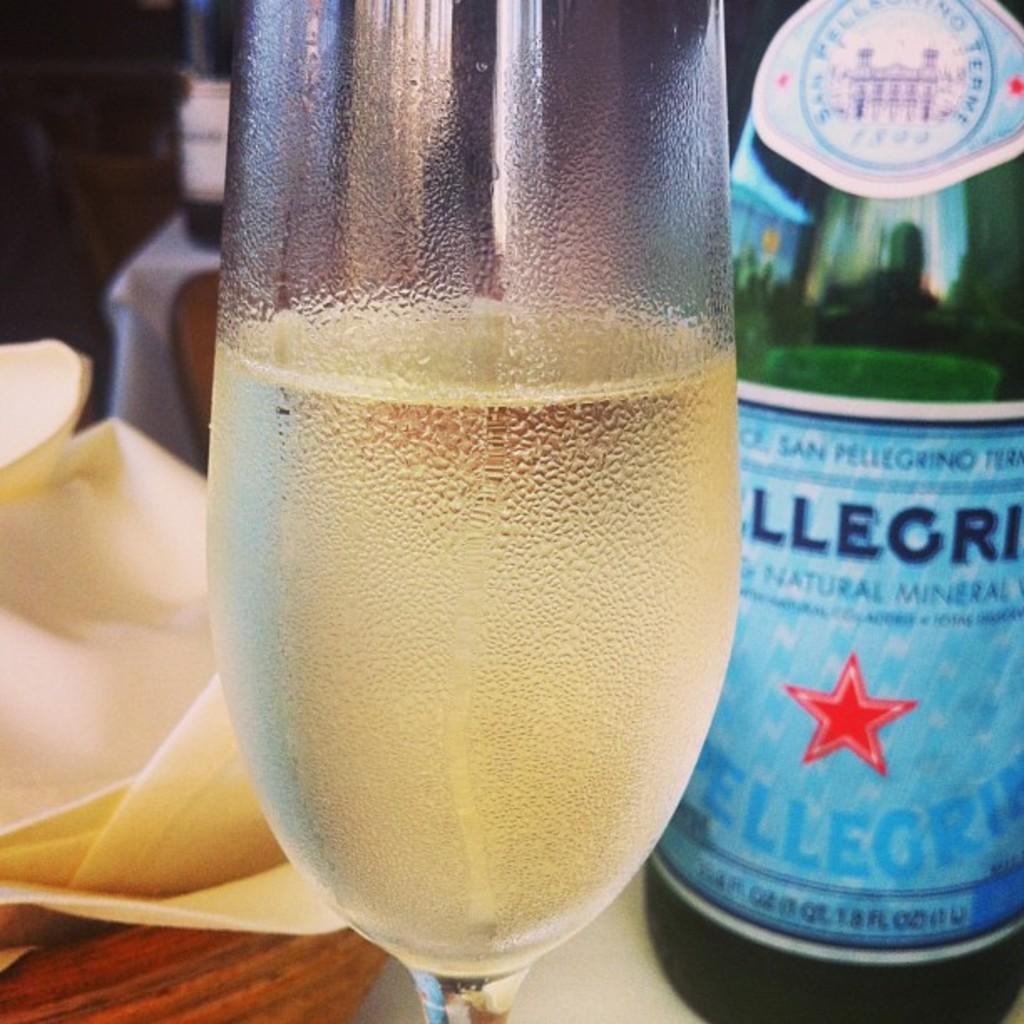What kind of sparkling water is it?
Make the answer very short. Pellegrino. 